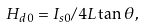<formula> <loc_0><loc_0><loc_500><loc_500>H _ { d 0 } = I _ { s 0 } / 4 L \tan \theta ,</formula> 